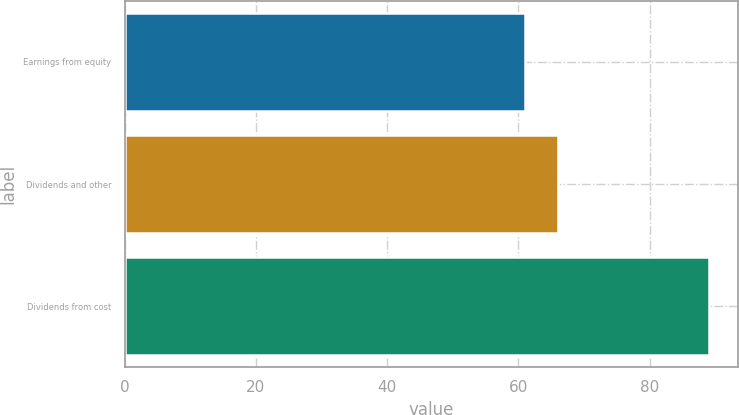Convert chart. <chart><loc_0><loc_0><loc_500><loc_500><bar_chart><fcel>Earnings from equity<fcel>Dividends and other<fcel>Dividends from cost<nl><fcel>61<fcel>66<fcel>89<nl></chart> 